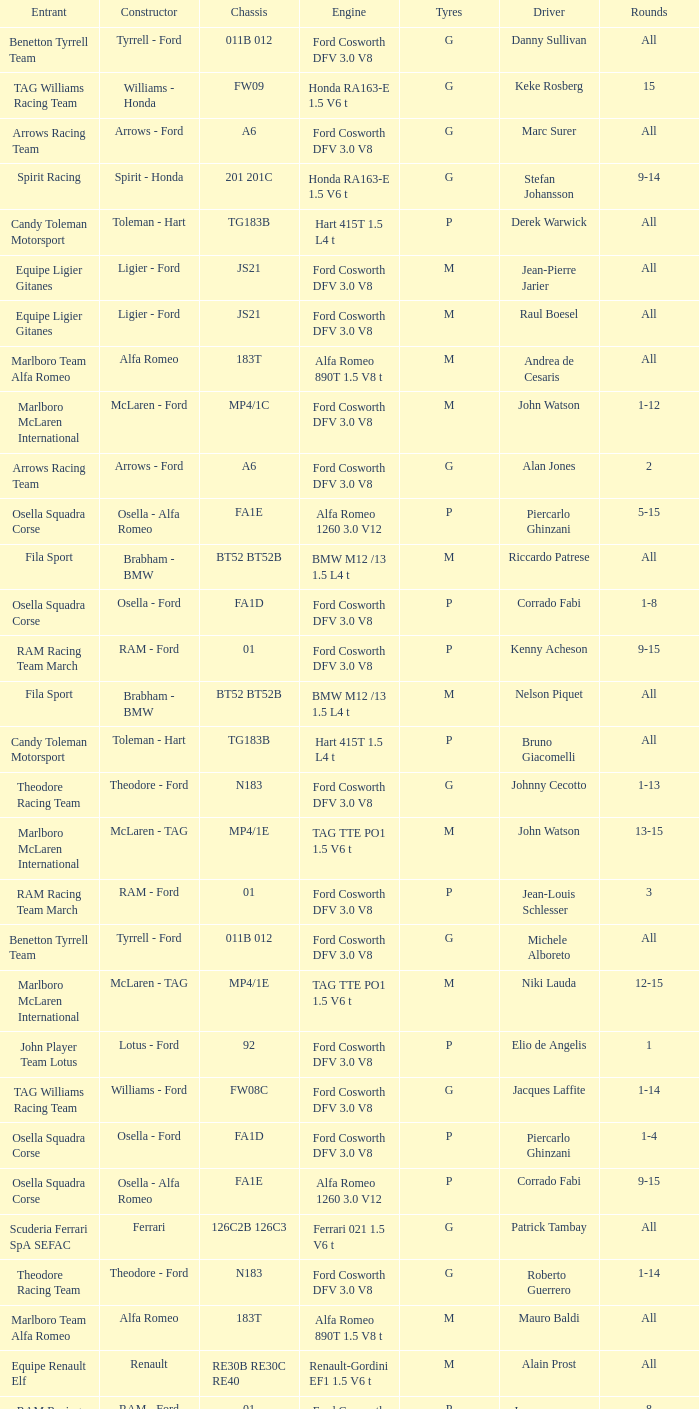Who is driver of the d6 chassis? Manfred Winkelhock. 